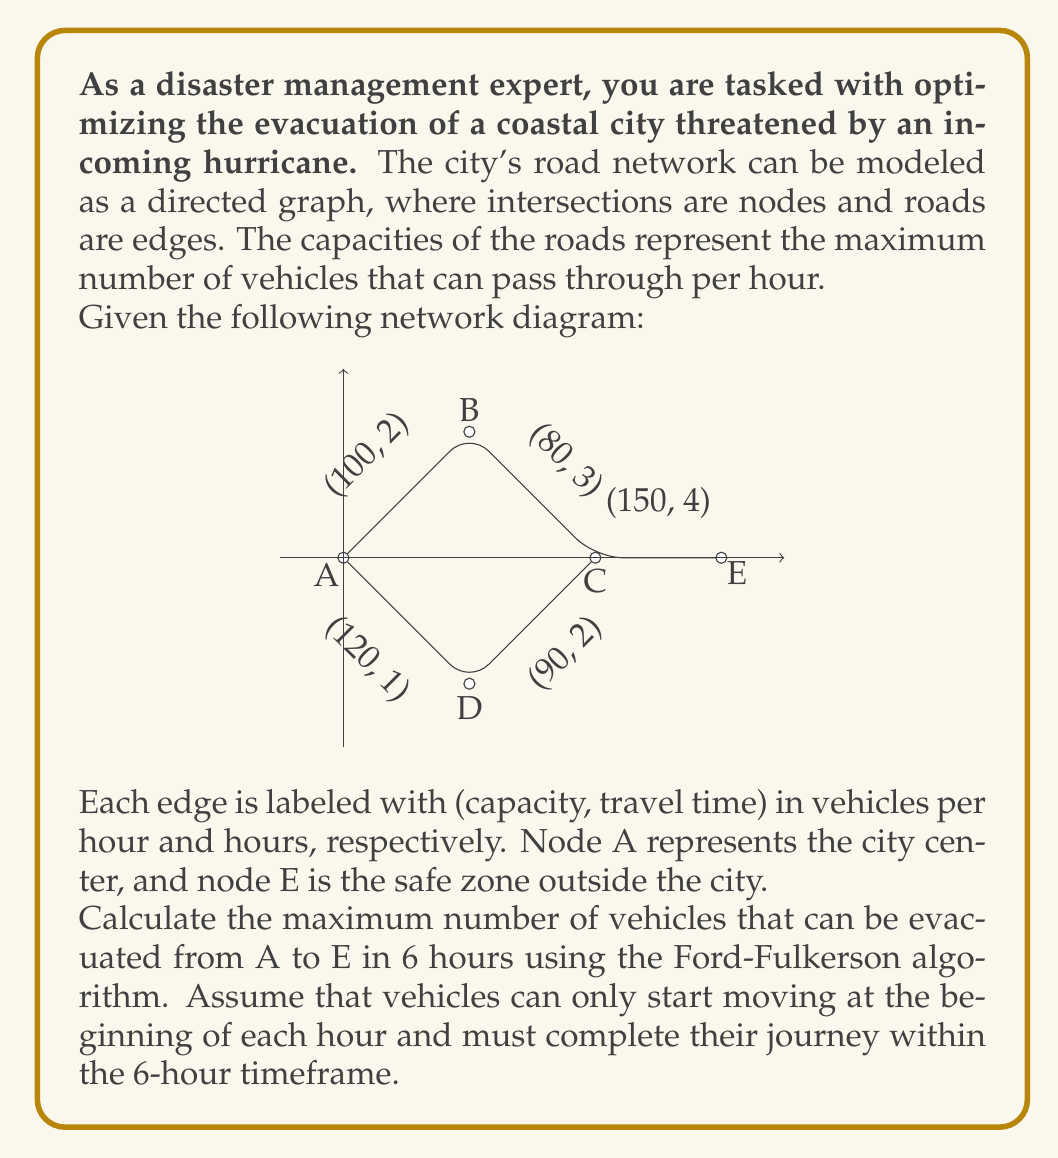Show me your answer to this math problem. To solve this problem, we need to use the Ford-Fulkerson algorithm while considering the time constraints. Let's approach this step-by-step:

1) First, we need to modify the network to account for the time constraint. We'll only consider paths that can be completed within 6 hours.

2) Possible paths from A to E:
   A -> B -> C -> E (2 + 3 + 4 = 9 hours) - Not valid
   A -> D -> C -> E (1 + 2 + 4 = 7 hours) - Not valid
   
3) Since no complete path from A to E can be traversed within 6 hours, we need to consider partial paths that vehicles can travel within this timeframe.

4) Possible partial paths:
   A -> B -> C (2 + 3 = 5 hours) - Valid
   A -> D -> C (1 + 2 = 3 hours) - Valid

5) Now, we can apply the Ford-Fulkerson algorithm to find the maximum flow from A to C within 6 hours.

6) Iteration 1:
   Path: A -> B -> C
   Min capacity: min(100, 80) = 80
   Flow: 80 * (6/5) = 96 (as we can repeat this flow every 5 hours)

7) Iteration 2:
   Path: A -> D -> C
   Min capacity: min(120, 90) = 90
   Flow: 90 * (6/3) = 180 (as we can repeat this flow every 3 hours)

8) Total maximum flow = 96 + 180 = 276

Therefore, the maximum number of vehicles that can be evacuated from A to C (not E) in 6 hours is 276.
Answer: 276 vehicles 